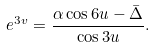<formula> <loc_0><loc_0><loc_500><loc_500>e ^ { 3 v } = \frac { \alpha \cos 6 u - \bar { \Delta } } { \cos 3 u } .</formula> 